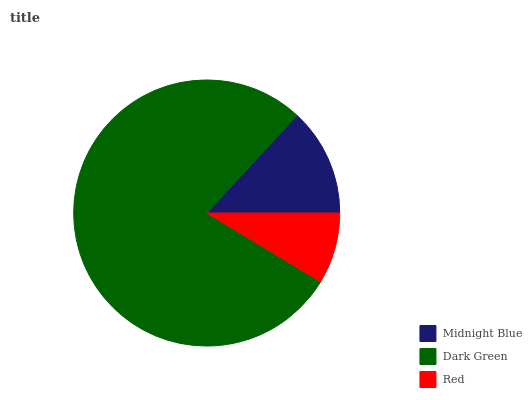Is Red the minimum?
Answer yes or no. Yes. Is Dark Green the maximum?
Answer yes or no. Yes. Is Dark Green the minimum?
Answer yes or no. No. Is Red the maximum?
Answer yes or no. No. Is Dark Green greater than Red?
Answer yes or no. Yes. Is Red less than Dark Green?
Answer yes or no. Yes. Is Red greater than Dark Green?
Answer yes or no. No. Is Dark Green less than Red?
Answer yes or no. No. Is Midnight Blue the high median?
Answer yes or no. Yes. Is Midnight Blue the low median?
Answer yes or no. Yes. Is Dark Green the high median?
Answer yes or no. No. Is Dark Green the low median?
Answer yes or no. No. 